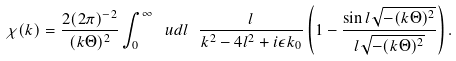<formula> <loc_0><loc_0><loc_500><loc_500>\chi ( k ) = \frac { 2 ( 2 \pi ) ^ { - 2 } } { ( k \Theta ) ^ { 2 } } \int _ { 0 } ^ { \infty } \ u d l \ \frac { l } { k ^ { 2 } - 4 l ^ { 2 } + i \epsilon k _ { 0 } } \left ( 1 - \frac { \sin l \sqrt { - ( k \Theta ) ^ { 2 } } } { l \sqrt { - ( k \Theta ) ^ { 2 } } } \right ) .</formula> 